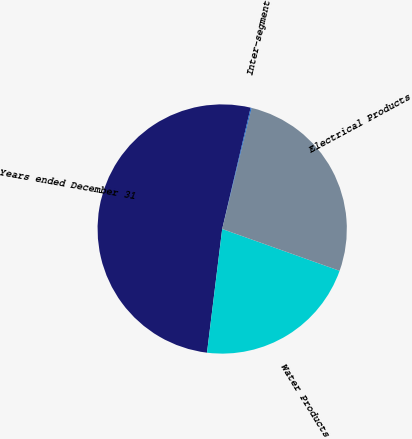Convert chart. <chart><loc_0><loc_0><loc_500><loc_500><pie_chart><fcel>Years ended December 31<fcel>Water Products<fcel>Electrical Products<fcel>Inter-segment<nl><fcel>51.72%<fcel>21.5%<fcel>26.65%<fcel>0.13%<nl></chart> 